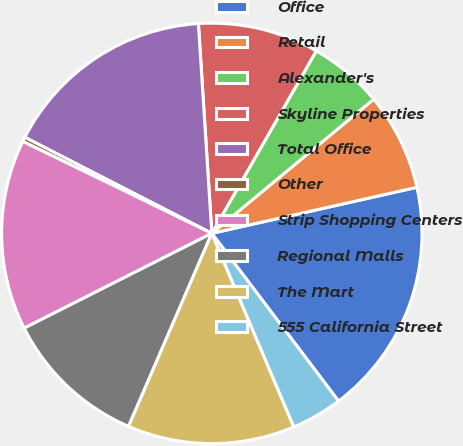Convert chart to OTSL. <chart><loc_0><loc_0><loc_500><loc_500><pie_chart><fcel>Office<fcel>Retail<fcel>Alexander's<fcel>Skyline Properties<fcel>Total Office<fcel>Other<fcel>Strip Shopping Centers<fcel>Regional Malls<fcel>The Mart<fcel>555 California Street<nl><fcel>18.22%<fcel>7.5%<fcel>5.71%<fcel>9.29%<fcel>16.43%<fcel>0.35%<fcel>14.65%<fcel>11.07%<fcel>12.86%<fcel>3.92%<nl></chart> 